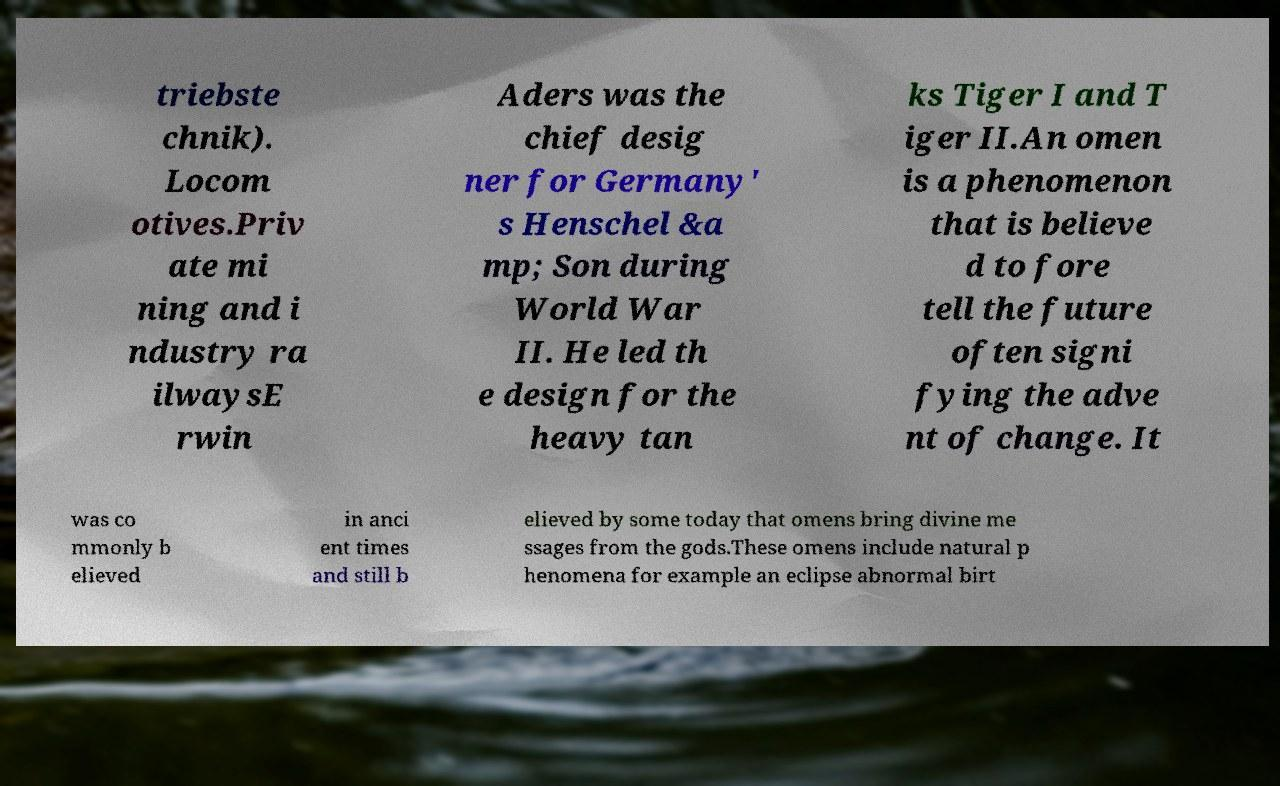Can you read and provide the text displayed in the image?This photo seems to have some interesting text. Can you extract and type it out for me? triebste chnik). Locom otives.Priv ate mi ning and i ndustry ra ilwaysE rwin Aders was the chief desig ner for Germany' s Henschel &a mp; Son during World War II. He led th e design for the heavy tan ks Tiger I and T iger II.An omen is a phenomenon that is believe d to fore tell the future often signi fying the adve nt of change. It was co mmonly b elieved in anci ent times and still b elieved by some today that omens bring divine me ssages from the gods.These omens include natural p henomena for example an eclipse abnormal birt 